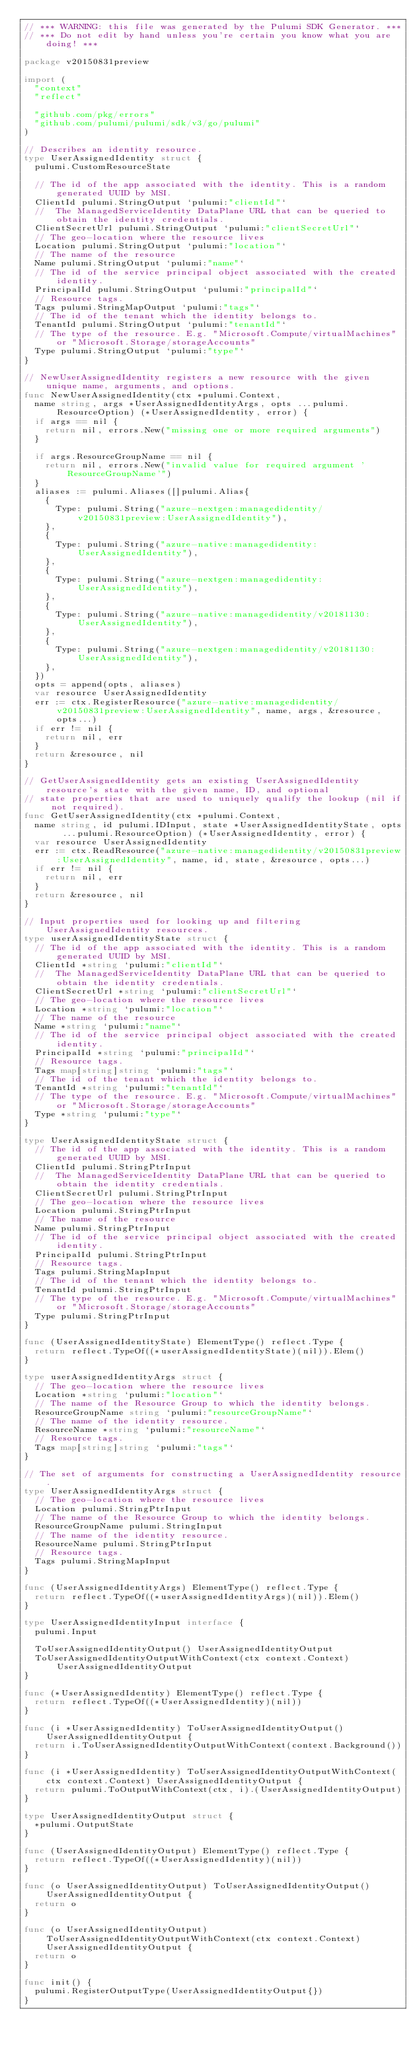<code> <loc_0><loc_0><loc_500><loc_500><_Go_>// *** WARNING: this file was generated by the Pulumi SDK Generator. ***
// *** Do not edit by hand unless you're certain you know what you are doing! ***

package v20150831preview

import (
	"context"
	"reflect"

	"github.com/pkg/errors"
	"github.com/pulumi/pulumi/sdk/v3/go/pulumi"
)

// Describes an identity resource.
type UserAssignedIdentity struct {
	pulumi.CustomResourceState

	// The id of the app associated with the identity. This is a random generated UUID by MSI.
	ClientId pulumi.StringOutput `pulumi:"clientId"`
	//  The ManagedServiceIdentity DataPlane URL that can be queried to obtain the identity credentials.
	ClientSecretUrl pulumi.StringOutput `pulumi:"clientSecretUrl"`
	// The geo-location where the resource lives
	Location pulumi.StringOutput `pulumi:"location"`
	// The name of the resource
	Name pulumi.StringOutput `pulumi:"name"`
	// The id of the service principal object associated with the created identity.
	PrincipalId pulumi.StringOutput `pulumi:"principalId"`
	// Resource tags.
	Tags pulumi.StringMapOutput `pulumi:"tags"`
	// The id of the tenant which the identity belongs to.
	TenantId pulumi.StringOutput `pulumi:"tenantId"`
	// The type of the resource. E.g. "Microsoft.Compute/virtualMachines" or "Microsoft.Storage/storageAccounts"
	Type pulumi.StringOutput `pulumi:"type"`
}

// NewUserAssignedIdentity registers a new resource with the given unique name, arguments, and options.
func NewUserAssignedIdentity(ctx *pulumi.Context,
	name string, args *UserAssignedIdentityArgs, opts ...pulumi.ResourceOption) (*UserAssignedIdentity, error) {
	if args == nil {
		return nil, errors.New("missing one or more required arguments")
	}

	if args.ResourceGroupName == nil {
		return nil, errors.New("invalid value for required argument 'ResourceGroupName'")
	}
	aliases := pulumi.Aliases([]pulumi.Alias{
		{
			Type: pulumi.String("azure-nextgen:managedidentity/v20150831preview:UserAssignedIdentity"),
		},
		{
			Type: pulumi.String("azure-native:managedidentity:UserAssignedIdentity"),
		},
		{
			Type: pulumi.String("azure-nextgen:managedidentity:UserAssignedIdentity"),
		},
		{
			Type: pulumi.String("azure-native:managedidentity/v20181130:UserAssignedIdentity"),
		},
		{
			Type: pulumi.String("azure-nextgen:managedidentity/v20181130:UserAssignedIdentity"),
		},
	})
	opts = append(opts, aliases)
	var resource UserAssignedIdentity
	err := ctx.RegisterResource("azure-native:managedidentity/v20150831preview:UserAssignedIdentity", name, args, &resource, opts...)
	if err != nil {
		return nil, err
	}
	return &resource, nil
}

// GetUserAssignedIdentity gets an existing UserAssignedIdentity resource's state with the given name, ID, and optional
// state properties that are used to uniquely qualify the lookup (nil if not required).
func GetUserAssignedIdentity(ctx *pulumi.Context,
	name string, id pulumi.IDInput, state *UserAssignedIdentityState, opts ...pulumi.ResourceOption) (*UserAssignedIdentity, error) {
	var resource UserAssignedIdentity
	err := ctx.ReadResource("azure-native:managedidentity/v20150831preview:UserAssignedIdentity", name, id, state, &resource, opts...)
	if err != nil {
		return nil, err
	}
	return &resource, nil
}

// Input properties used for looking up and filtering UserAssignedIdentity resources.
type userAssignedIdentityState struct {
	// The id of the app associated with the identity. This is a random generated UUID by MSI.
	ClientId *string `pulumi:"clientId"`
	//  The ManagedServiceIdentity DataPlane URL that can be queried to obtain the identity credentials.
	ClientSecretUrl *string `pulumi:"clientSecretUrl"`
	// The geo-location where the resource lives
	Location *string `pulumi:"location"`
	// The name of the resource
	Name *string `pulumi:"name"`
	// The id of the service principal object associated with the created identity.
	PrincipalId *string `pulumi:"principalId"`
	// Resource tags.
	Tags map[string]string `pulumi:"tags"`
	// The id of the tenant which the identity belongs to.
	TenantId *string `pulumi:"tenantId"`
	// The type of the resource. E.g. "Microsoft.Compute/virtualMachines" or "Microsoft.Storage/storageAccounts"
	Type *string `pulumi:"type"`
}

type UserAssignedIdentityState struct {
	// The id of the app associated with the identity. This is a random generated UUID by MSI.
	ClientId pulumi.StringPtrInput
	//  The ManagedServiceIdentity DataPlane URL that can be queried to obtain the identity credentials.
	ClientSecretUrl pulumi.StringPtrInput
	// The geo-location where the resource lives
	Location pulumi.StringPtrInput
	// The name of the resource
	Name pulumi.StringPtrInput
	// The id of the service principal object associated with the created identity.
	PrincipalId pulumi.StringPtrInput
	// Resource tags.
	Tags pulumi.StringMapInput
	// The id of the tenant which the identity belongs to.
	TenantId pulumi.StringPtrInput
	// The type of the resource. E.g. "Microsoft.Compute/virtualMachines" or "Microsoft.Storage/storageAccounts"
	Type pulumi.StringPtrInput
}

func (UserAssignedIdentityState) ElementType() reflect.Type {
	return reflect.TypeOf((*userAssignedIdentityState)(nil)).Elem()
}

type userAssignedIdentityArgs struct {
	// The geo-location where the resource lives
	Location *string `pulumi:"location"`
	// The name of the Resource Group to which the identity belongs.
	ResourceGroupName string `pulumi:"resourceGroupName"`
	// The name of the identity resource.
	ResourceName *string `pulumi:"resourceName"`
	// Resource tags.
	Tags map[string]string `pulumi:"tags"`
}

// The set of arguments for constructing a UserAssignedIdentity resource.
type UserAssignedIdentityArgs struct {
	// The geo-location where the resource lives
	Location pulumi.StringPtrInput
	// The name of the Resource Group to which the identity belongs.
	ResourceGroupName pulumi.StringInput
	// The name of the identity resource.
	ResourceName pulumi.StringPtrInput
	// Resource tags.
	Tags pulumi.StringMapInput
}

func (UserAssignedIdentityArgs) ElementType() reflect.Type {
	return reflect.TypeOf((*userAssignedIdentityArgs)(nil)).Elem()
}

type UserAssignedIdentityInput interface {
	pulumi.Input

	ToUserAssignedIdentityOutput() UserAssignedIdentityOutput
	ToUserAssignedIdentityOutputWithContext(ctx context.Context) UserAssignedIdentityOutput
}

func (*UserAssignedIdentity) ElementType() reflect.Type {
	return reflect.TypeOf((*UserAssignedIdentity)(nil))
}

func (i *UserAssignedIdentity) ToUserAssignedIdentityOutput() UserAssignedIdentityOutput {
	return i.ToUserAssignedIdentityOutputWithContext(context.Background())
}

func (i *UserAssignedIdentity) ToUserAssignedIdentityOutputWithContext(ctx context.Context) UserAssignedIdentityOutput {
	return pulumi.ToOutputWithContext(ctx, i).(UserAssignedIdentityOutput)
}

type UserAssignedIdentityOutput struct {
	*pulumi.OutputState
}

func (UserAssignedIdentityOutput) ElementType() reflect.Type {
	return reflect.TypeOf((*UserAssignedIdentity)(nil))
}

func (o UserAssignedIdentityOutput) ToUserAssignedIdentityOutput() UserAssignedIdentityOutput {
	return o
}

func (o UserAssignedIdentityOutput) ToUserAssignedIdentityOutputWithContext(ctx context.Context) UserAssignedIdentityOutput {
	return o
}

func init() {
	pulumi.RegisterOutputType(UserAssignedIdentityOutput{})
}
</code> 